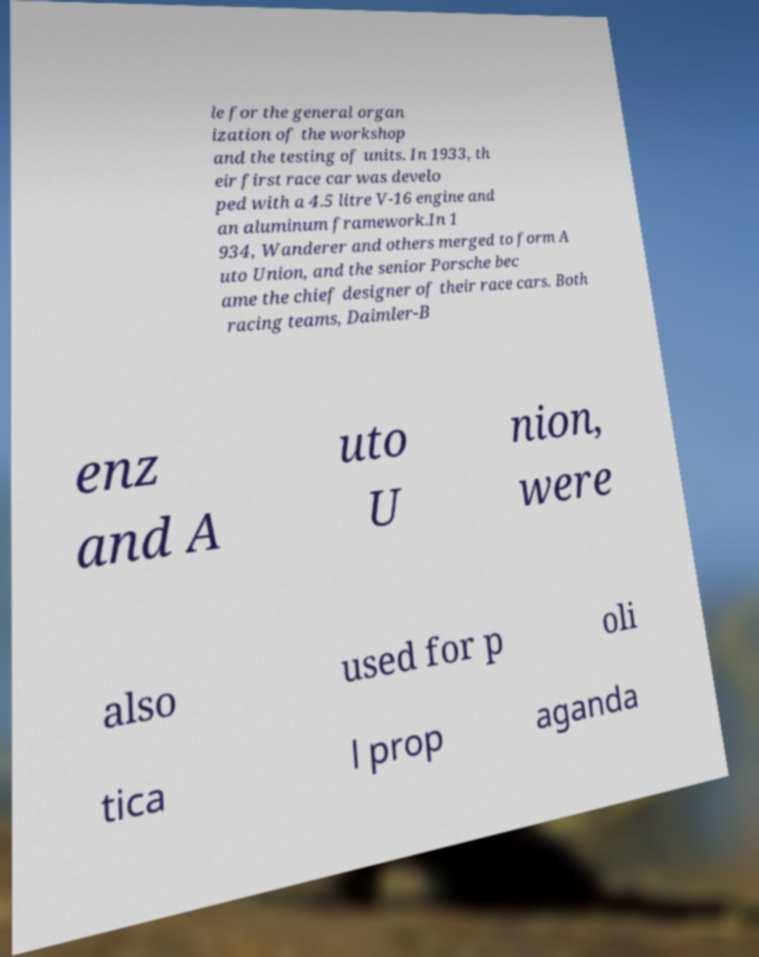Could you assist in decoding the text presented in this image and type it out clearly? le for the general organ ization of the workshop and the testing of units. In 1933, th eir first race car was develo ped with a 4.5 litre V-16 engine and an aluminum framework.In 1 934, Wanderer and others merged to form A uto Union, and the senior Porsche bec ame the chief designer of their race cars. Both racing teams, Daimler-B enz and A uto U nion, were also used for p oli tica l prop aganda 